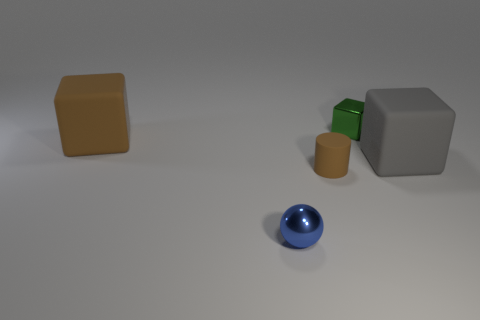Are there the same number of balls that are left of the green metallic block and large gray objects?
Offer a terse response. Yes. There is a shiny object behind the large brown matte object; is its shape the same as the object that is on the left side of the small metallic sphere?
Your response must be concise. Yes. What is the material of the large brown thing that is the same shape as the green metallic object?
Keep it short and to the point. Rubber. What color is the thing that is in front of the brown block and to the right of the matte cylinder?
Ensure brevity in your answer.  Gray. There is a tiny blue ball that is in front of the tiny object that is behind the big brown matte block; are there any big brown rubber blocks that are to the left of it?
Keep it short and to the point. Yes. How many objects are either small green objects or large brown matte cylinders?
Make the answer very short. 1. Is the blue object made of the same material as the large block that is on the right side of the small blue shiny sphere?
Offer a terse response. No. Is there anything else of the same color as the metallic cube?
Give a very brief answer. No. How many things are either blocks that are in front of the shiny block or cubes to the left of the big gray block?
Provide a short and direct response. 3. What shape is the small thing that is in front of the large brown block and behind the small blue ball?
Your answer should be very brief. Cylinder. 